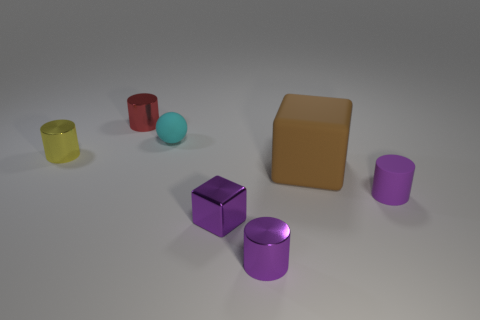Add 3 red balls. How many objects exist? 10 Subtract all cylinders. How many objects are left? 3 Add 2 tiny yellow cylinders. How many tiny yellow cylinders exist? 3 Subtract 0 gray balls. How many objects are left? 7 Subtract all small cylinders. Subtract all small purple metallic cylinders. How many objects are left? 2 Add 7 small cubes. How many small cubes are left? 8 